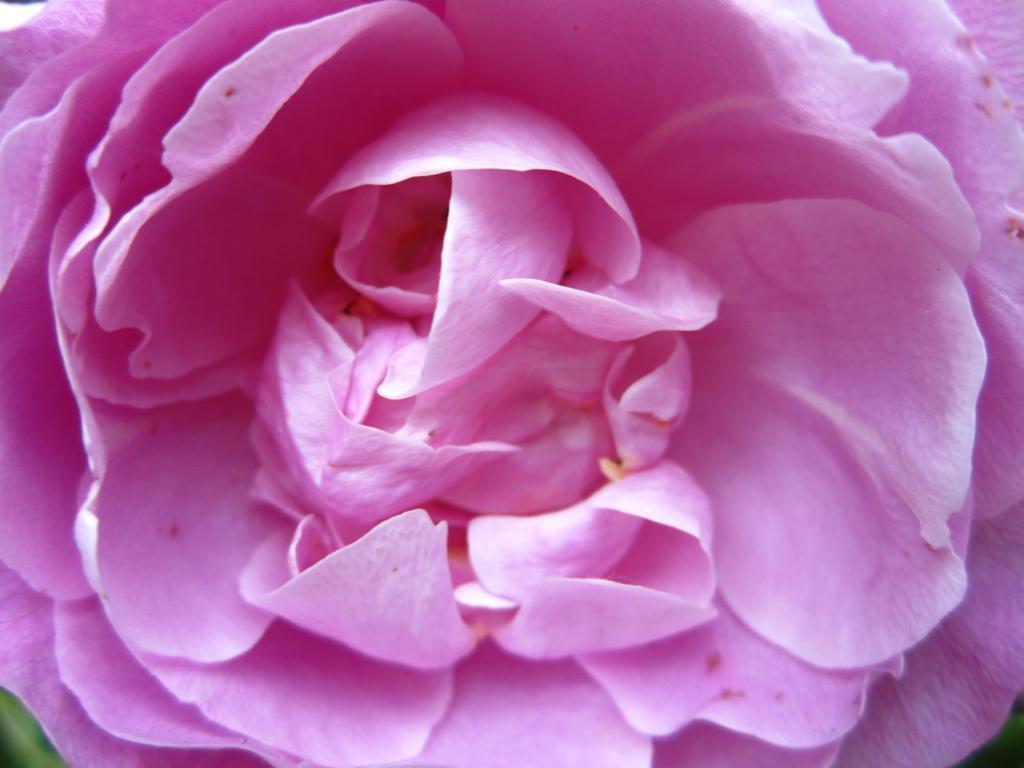Can you describe this image briefly? It is a zoomed in picture of a flower. 